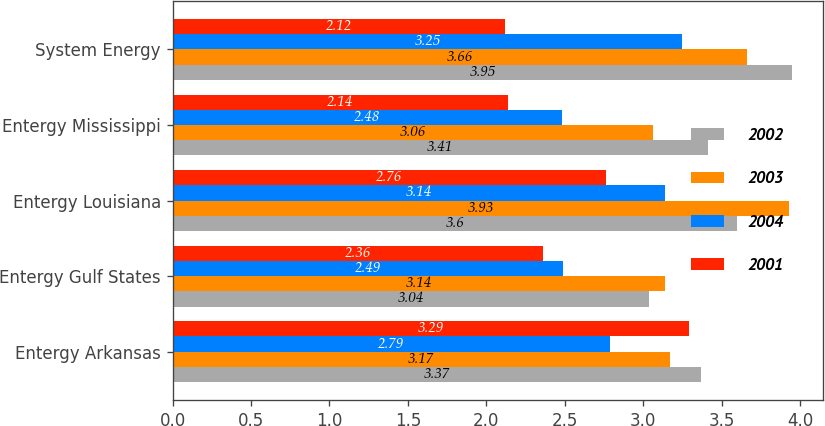Convert chart to OTSL. <chart><loc_0><loc_0><loc_500><loc_500><stacked_bar_chart><ecel><fcel>Entergy Arkansas<fcel>Entergy Gulf States<fcel>Entergy Louisiana<fcel>Entergy Mississippi<fcel>System Energy<nl><fcel>2002<fcel>3.37<fcel>3.04<fcel>3.6<fcel>3.41<fcel>3.95<nl><fcel>2003<fcel>3.17<fcel>3.14<fcel>3.93<fcel>3.06<fcel>3.66<nl><fcel>2004<fcel>2.79<fcel>2.49<fcel>3.14<fcel>2.48<fcel>3.25<nl><fcel>2001<fcel>3.29<fcel>2.36<fcel>2.76<fcel>2.14<fcel>2.12<nl></chart> 